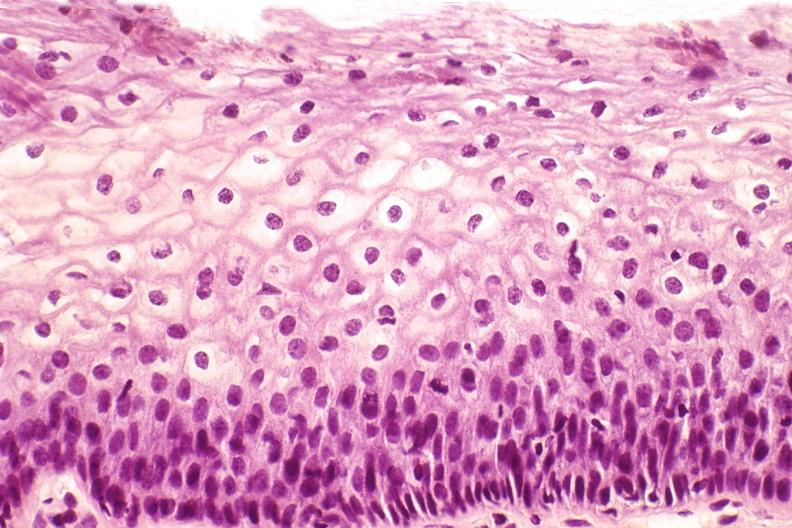does this image show cervix, mild dysplasia?
Answer the question using a single word or phrase. Yes 